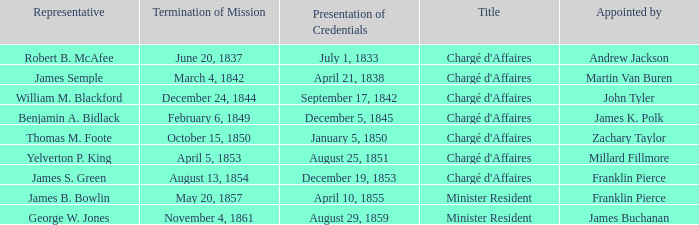What Title has a Termination of Mission for August 13, 1854? Chargé d'Affaires. 